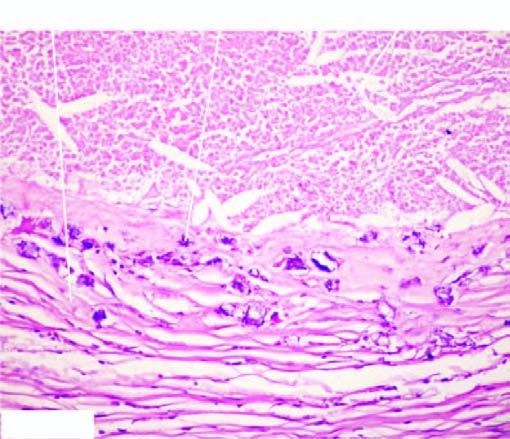what are basophilic granular while the periphery shows healed granulomas?
Answer the question using a single word or phrase. The deposits 